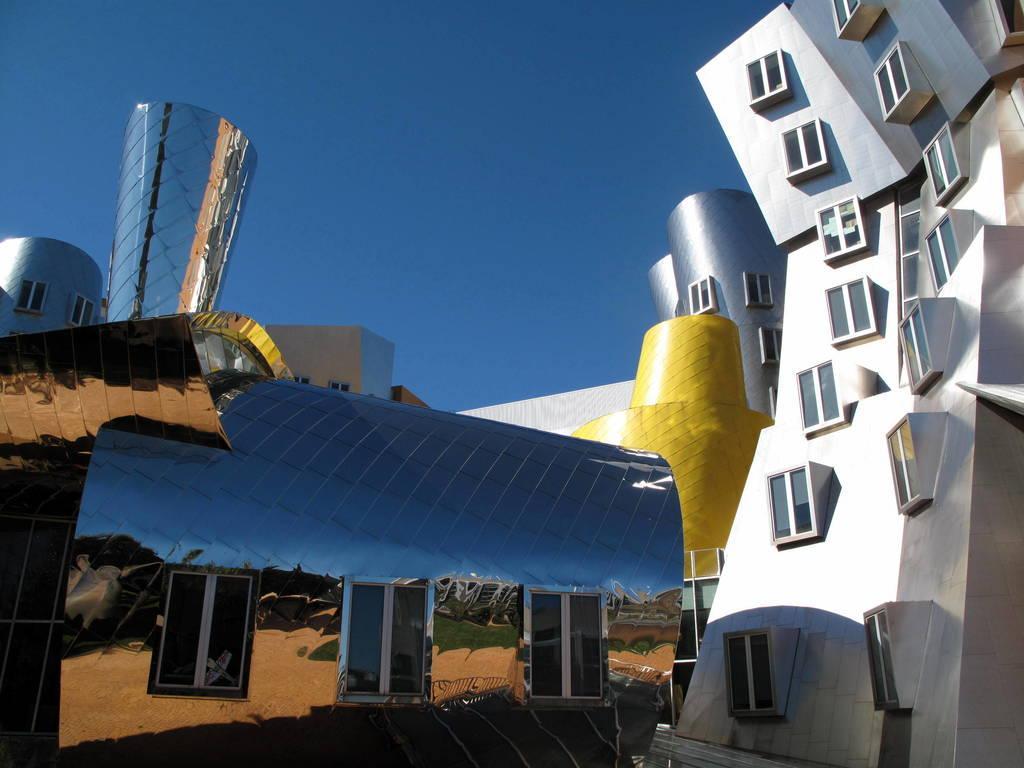Can you describe this image briefly? In this image we can see buildings and sky. 